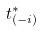Convert formula to latex. <formula><loc_0><loc_0><loc_500><loc_500>t _ { ( - i ) } ^ { * }</formula> 